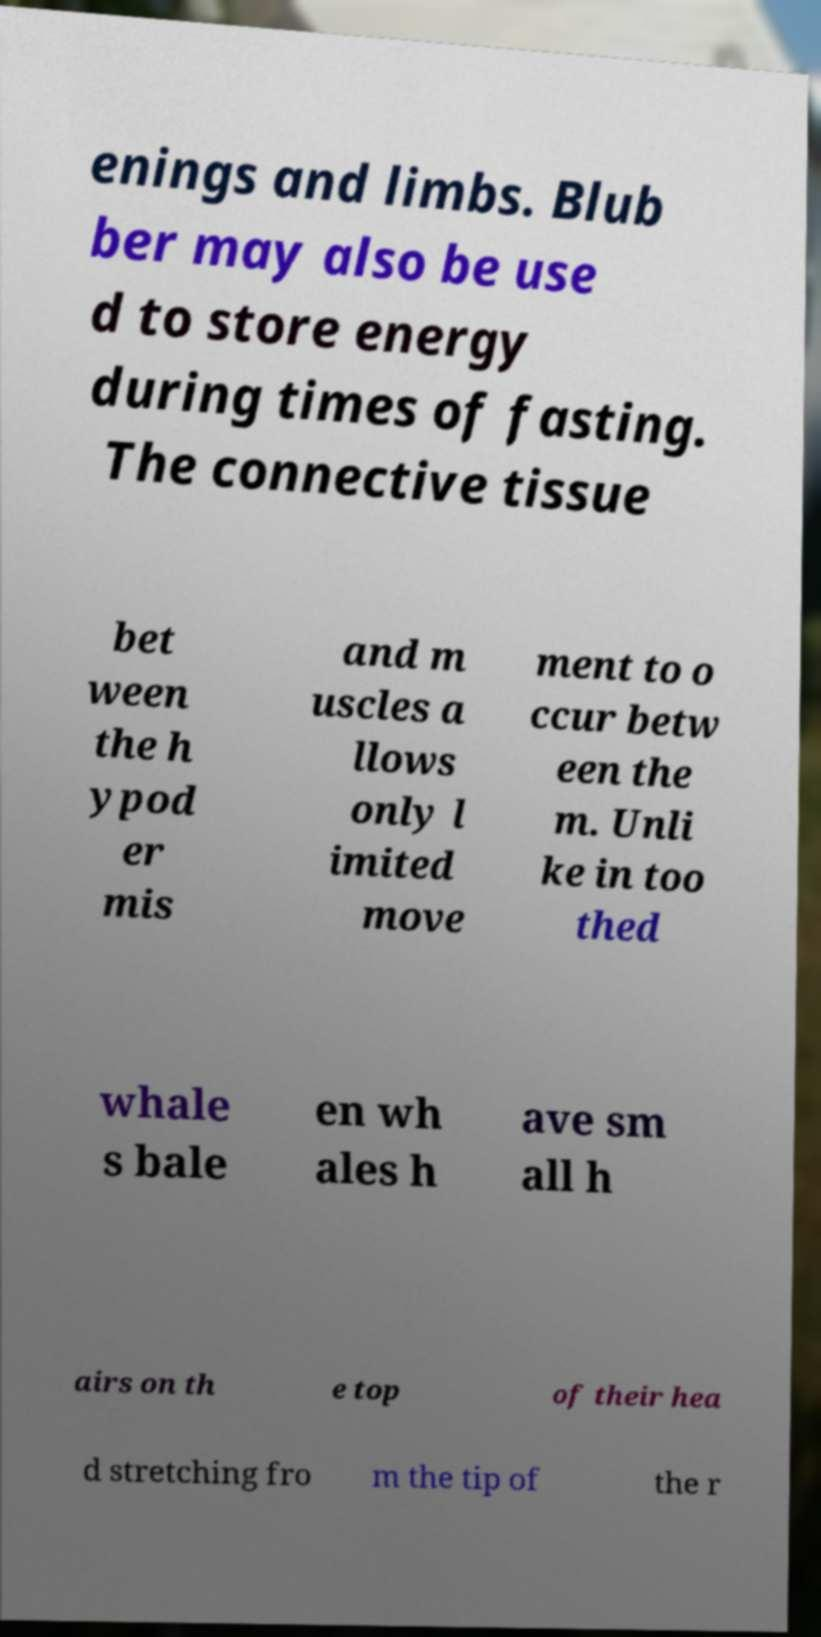For documentation purposes, I need the text within this image transcribed. Could you provide that? enings and limbs. Blub ber may also be use d to store energy during times of fasting. The connective tissue bet ween the h ypod er mis and m uscles a llows only l imited move ment to o ccur betw een the m. Unli ke in too thed whale s bale en wh ales h ave sm all h airs on th e top of their hea d stretching fro m the tip of the r 